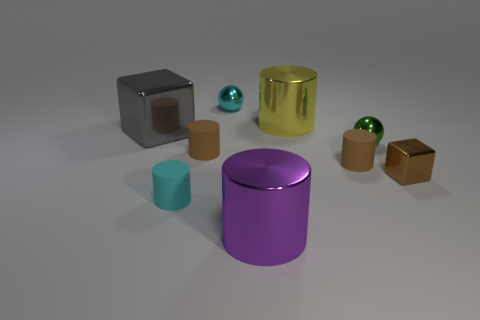How many other objects are the same material as the large gray block?
Your answer should be compact. 5. Does the rubber object on the right side of the big purple object have the same color as the small metal cube?
Ensure brevity in your answer.  Yes. There is a large cylinder in front of the cyan matte cylinder; is there a tiny brown cube in front of it?
Offer a very short reply. No. There is a large thing that is both behind the big purple cylinder and to the right of the large block; what material is it made of?
Offer a terse response. Metal. What shape is the tiny brown object that is the same material as the big yellow thing?
Your response must be concise. Cube. Is the material of the cyan object that is behind the tiny shiny block the same as the gray cube?
Make the answer very short. Yes. What material is the small cyan object that is in front of the gray thing?
Ensure brevity in your answer.  Rubber. There is a shiny block to the left of the tiny cyan object that is in front of the tiny cyan ball; how big is it?
Offer a very short reply. Large. What number of cyan spheres have the same size as the yellow cylinder?
Your response must be concise. 0. Does the metal cube that is on the right side of the gray block have the same color as the small cylinder that is right of the tiny cyan metallic ball?
Your response must be concise. Yes. 